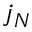Convert formula to latex. <formula><loc_0><loc_0><loc_500><loc_500>j _ { N }</formula> 